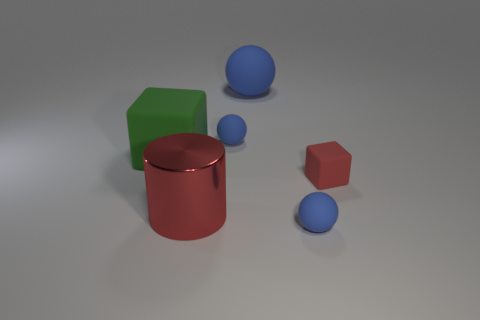Subtract all blue spheres. How many were subtracted if there are2blue spheres left? 1 Subtract all tiny blue balls. How many balls are left? 1 Add 1 small yellow objects. How many objects exist? 7 Subtract all red cubes. How many cubes are left? 1 Subtract 1 cubes. How many cubes are left? 1 Subtract all large red metal cylinders. Subtract all tiny red objects. How many objects are left? 4 Add 5 cylinders. How many cylinders are left? 6 Add 2 tiny blue spheres. How many tiny blue spheres exist? 4 Subtract 0 purple spheres. How many objects are left? 6 Subtract all cubes. How many objects are left? 4 